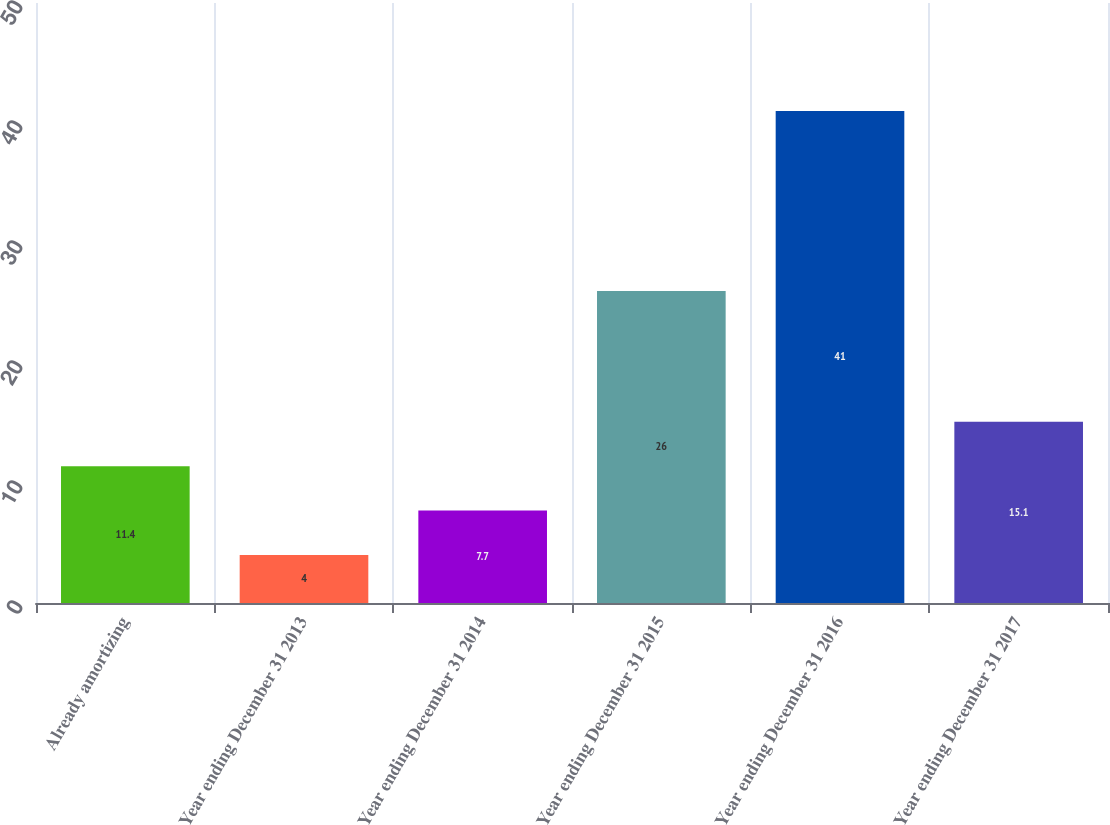<chart> <loc_0><loc_0><loc_500><loc_500><bar_chart><fcel>Already amortizing<fcel>Year ending December 31 2013<fcel>Year ending December 31 2014<fcel>Year ending December 31 2015<fcel>Year ending December 31 2016<fcel>Year ending December 31 2017<nl><fcel>11.4<fcel>4<fcel>7.7<fcel>26<fcel>41<fcel>15.1<nl></chart> 